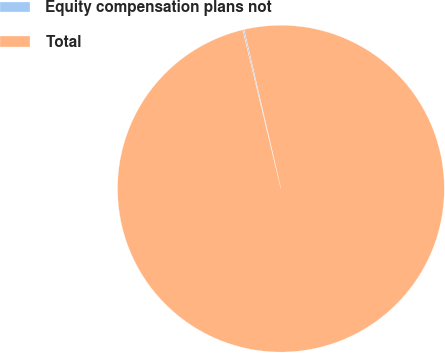Convert chart. <chart><loc_0><loc_0><loc_500><loc_500><pie_chart><fcel>Equity compensation plans not<fcel>Total<nl><fcel>0.14%<fcel>99.86%<nl></chart> 